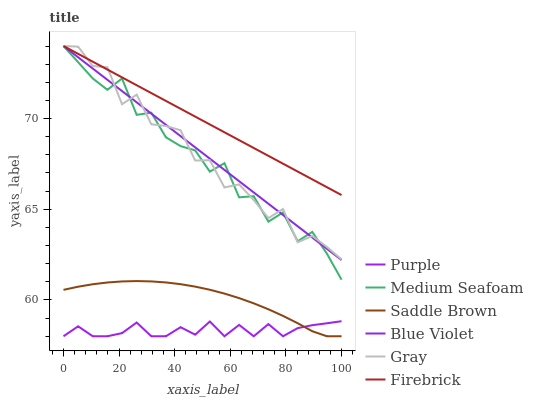Does Purple have the minimum area under the curve?
Answer yes or no. Yes. Does Firebrick have the maximum area under the curve?
Answer yes or no. Yes. Does Firebrick have the minimum area under the curve?
Answer yes or no. No. Does Purple have the maximum area under the curve?
Answer yes or no. No. Is Firebrick the smoothest?
Answer yes or no. Yes. Is Medium Seafoam the roughest?
Answer yes or no. Yes. Is Purple the smoothest?
Answer yes or no. No. Is Purple the roughest?
Answer yes or no. No. Does Purple have the lowest value?
Answer yes or no. Yes. Does Firebrick have the lowest value?
Answer yes or no. No. Does Blue Violet have the highest value?
Answer yes or no. Yes. Does Purple have the highest value?
Answer yes or no. No. Is Saddle Brown less than Blue Violet?
Answer yes or no. Yes. Is Blue Violet greater than Purple?
Answer yes or no. Yes. Does Medium Seafoam intersect Gray?
Answer yes or no. Yes. Is Medium Seafoam less than Gray?
Answer yes or no. No. Is Medium Seafoam greater than Gray?
Answer yes or no. No. Does Saddle Brown intersect Blue Violet?
Answer yes or no. No. 